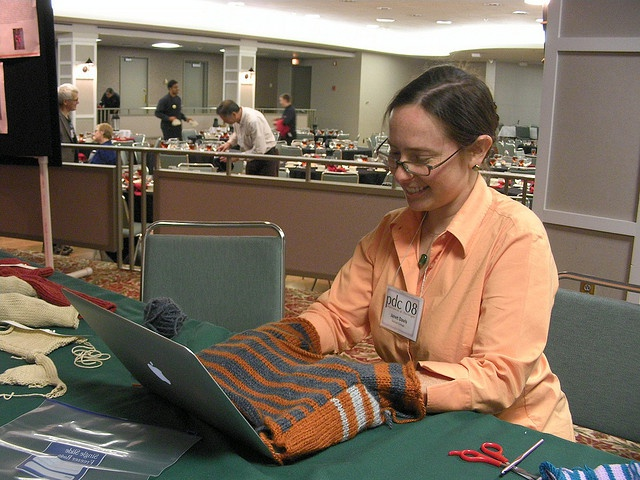Describe the objects in this image and their specific colors. I can see people in lightpink, tan, and salmon tones, chair in lightpink, gray, maroon, and black tones, chair in lightpink, gray, and black tones, laptop in lightpink, black, gray, and darkgreen tones, and people in lightpink, black, lightgray, gray, and darkgray tones in this image. 